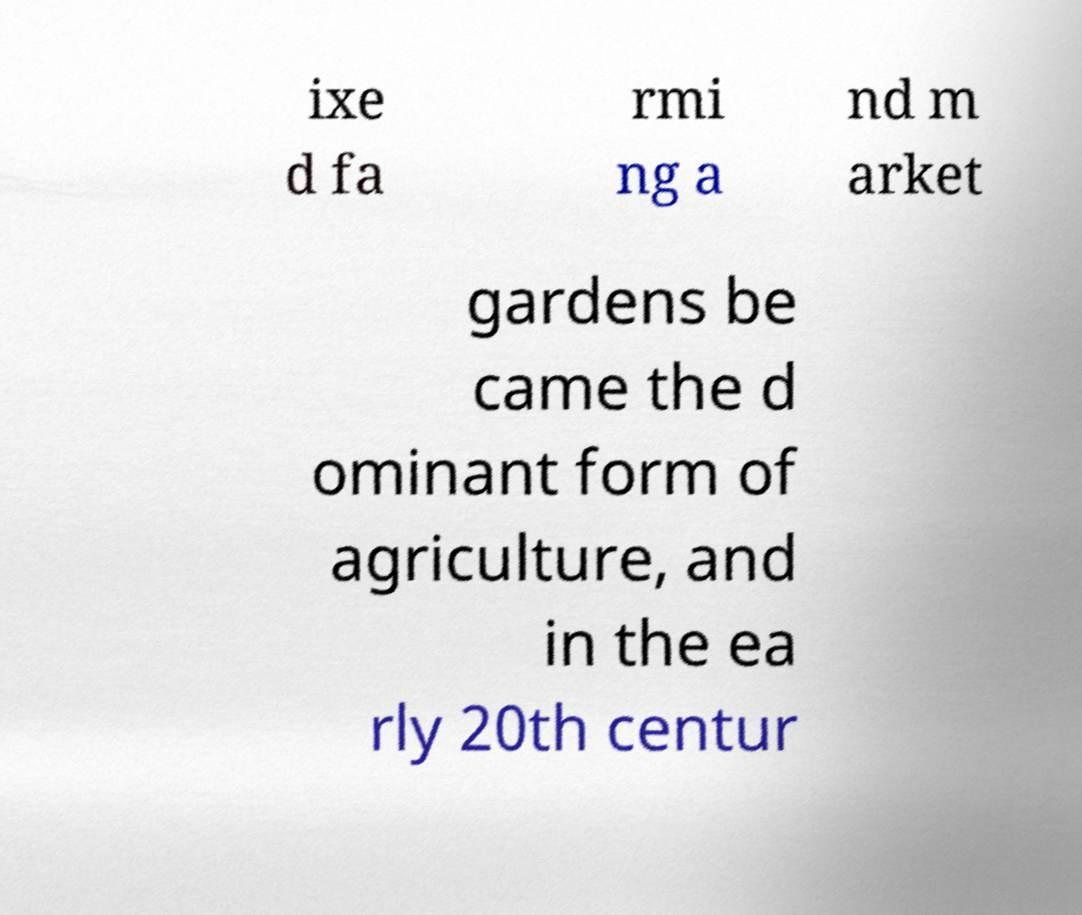For documentation purposes, I need the text within this image transcribed. Could you provide that? ixe d fa rmi ng a nd m arket gardens be came the d ominant form of agriculture, and in the ea rly 20th centur 